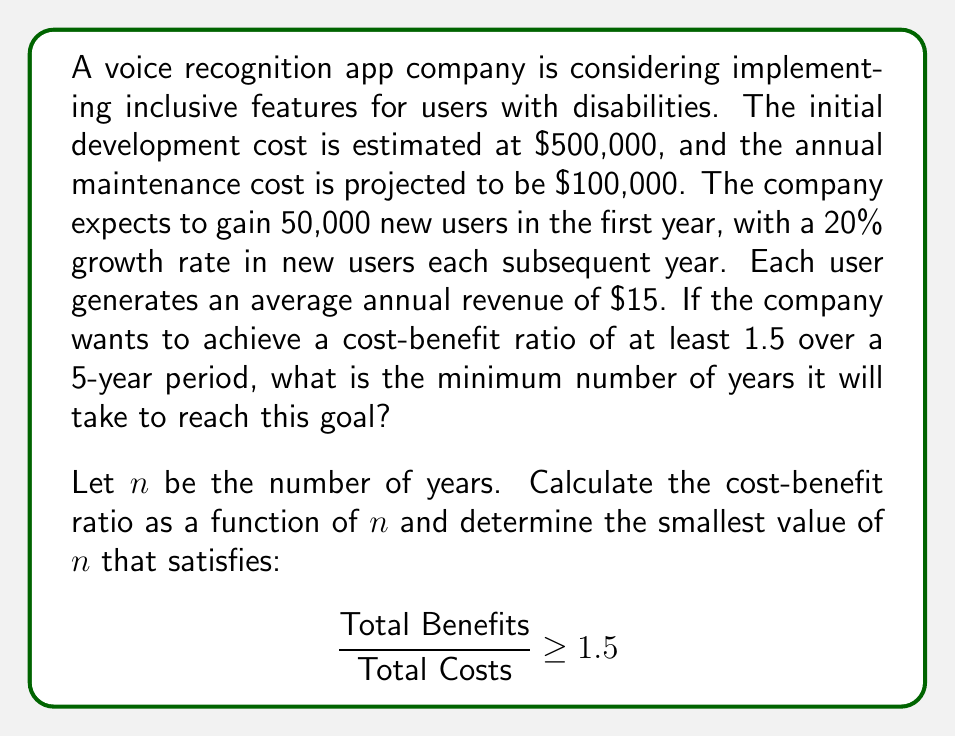Solve this math problem. To solve this problem, we need to calculate the total costs and total benefits over $n$ years, then set up an inequality to find the minimum value of $n$ that satisfies the given condition.

1. Calculate Total Costs:
   Initial cost + Annual maintenance cost * n years
   $$TC = 500,000 + 100,000n$$

2. Calculate Total Benefits:
   We need to sum up the revenue generated by new users each year, accounting for the 20% growth rate.
   Year 1: 50,000 * $15 = $750,000
   Year 2: (50,000 * 1.2) * $15 = $900,000
   Year 3: (50,000 * 1.2^2) * $15 = $1,080,000
   ...and so on.

   This forms a geometric series with first term $a = 750,000$ and common ratio $r = 1.2$
   The sum of this series for $n$ years is given by:
   $$TB = a\frac{1-r^n}{1-r} = 750,000\frac{1-1.2^n}{1-1.2} = 3,750,000(1-1.2^n)$$

3. Set up the inequality:
   $$\frac{\text{Total Benefits}}{\text{Total Costs}} \geq 1.5$$
   $$\frac{3,750,000(1-1.2^n)}{500,000 + 100,000n} \geq 1.5$$

4. Solve the inequality:
   $$3,750,000(1-1.2^n) \geq 1.5(500,000 + 100,000n)$$
   $$3,750,000 - 3,750,000 * 1.2^n \geq 750,000 + 150,000n$$
   $$3,000,000 - 3,750,000 * 1.2^n \geq 150,000n$$
   $$3,000,000 - 150,000n \geq 3,750,000 * 1.2^n$$
   $$20 - n \geq 25 * 1.2^n$$

5. Solve this equation numerically (e.g., using a graphing calculator or software).
   The smallest integer value of $n$ that satisfies this inequality is 5.

Therefore, it will take a minimum of 5 years to achieve a cost-benefit ratio of at least 1.5.
Answer: 5 years 